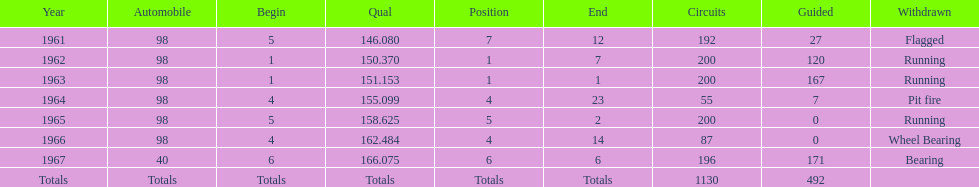What year(s) did parnelli finish at least 4th or better? 1963, 1965. 